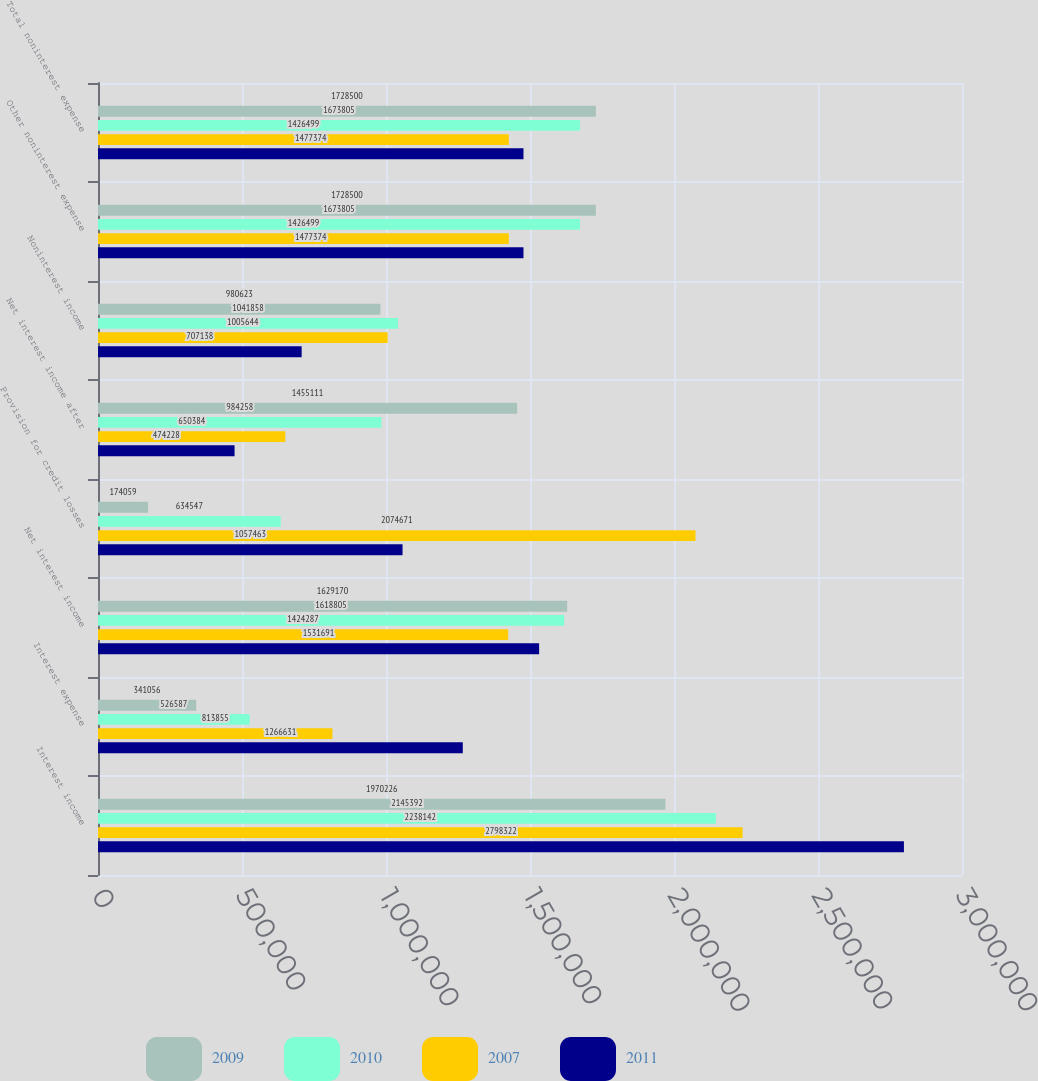Convert chart. <chart><loc_0><loc_0><loc_500><loc_500><stacked_bar_chart><ecel><fcel>Interest income<fcel>Interest expense<fcel>Net interest income<fcel>Provision for credit losses<fcel>Net interest income after<fcel>Noninterest income<fcel>Other noninterest expense<fcel>Total noninterest expense<nl><fcel>2009<fcel>1.97023e+06<fcel>341056<fcel>1.62917e+06<fcel>174059<fcel>1.45511e+06<fcel>980623<fcel>1.7285e+06<fcel>1.7285e+06<nl><fcel>2010<fcel>2.14539e+06<fcel>526587<fcel>1.6188e+06<fcel>634547<fcel>984258<fcel>1.04186e+06<fcel>1.6738e+06<fcel>1.6738e+06<nl><fcel>2007<fcel>2.23814e+06<fcel>813855<fcel>1.42429e+06<fcel>2.07467e+06<fcel>650384<fcel>1.00564e+06<fcel>1.4265e+06<fcel>1.4265e+06<nl><fcel>2011<fcel>2.79832e+06<fcel>1.26663e+06<fcel>1.53169e+06<fcel>1.05746e+06<fcel>474228<fcel>707138<fcel>1.47737e+06<fcel>1.47737e+06<nl></chart> 